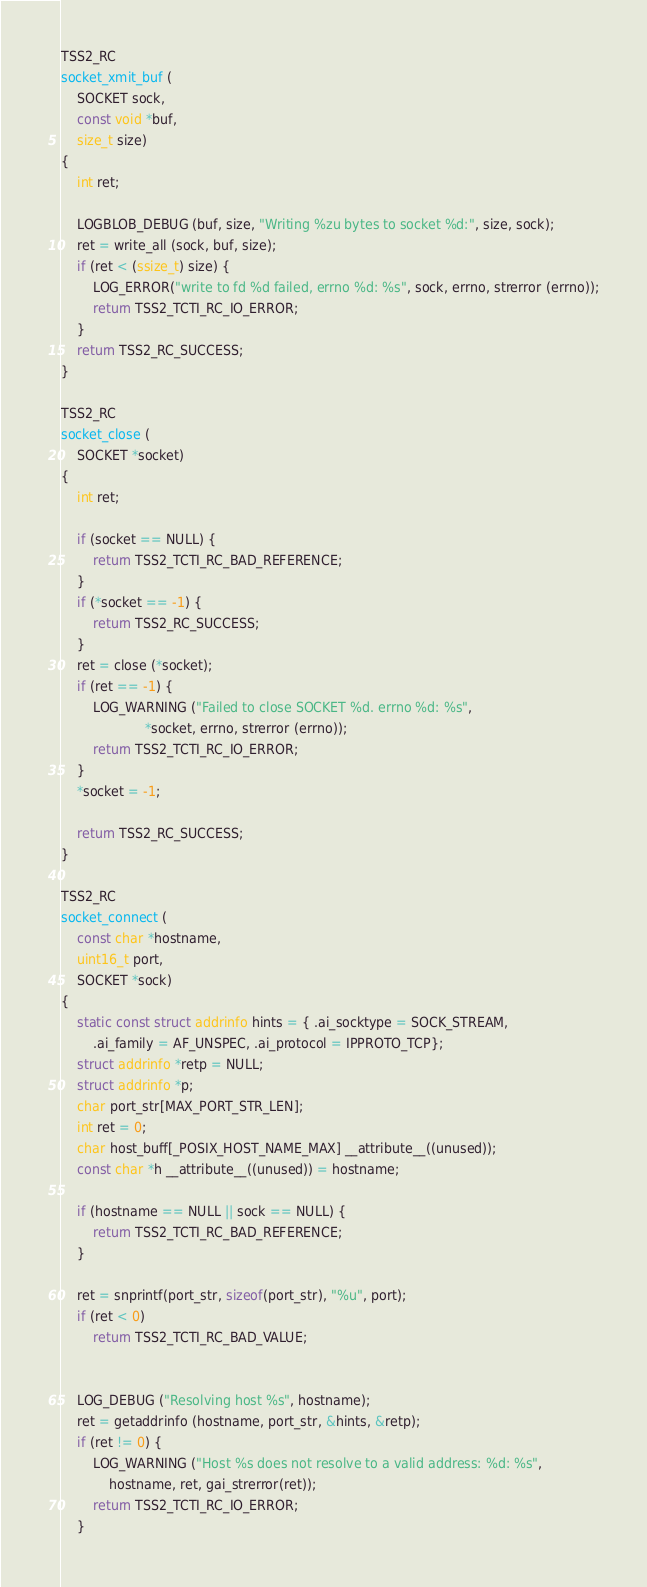<code> <loc_0><loc_0><loc_500><loc_500><_C_>TSS2_RC
socket_xmit_buf (
    SOCKET sock,
    const void *buf,
    size_t size)
{
    int ret;

    LOGBLOB_DEBUG (buf, size, "Writing %zu bytes to socket %d:", size, sock);
    ret = write_all (sock, buf, size);
    if (ret < (ssize_t) size) {
        LOG_ERROR("write to fd %d failed, errno %d: %s", sock, errno, strerror (errno));
        return TSS2_TCTI_RC_IO_ERROR;
    }
    return TSS2_RC_SUCCESS;
}

TSS2_RC
socket_close (
    SOCKET *socket)
{
    int ret;

    if (socket == NULL) {
        return TSS2_TCTI_RC_BAD_REFERENCE;
    }
    if (*socket == -1) {
        return TSS2_RC_SUCCESS;
    }
    ret = close (*socket);
    if (ret == -1) {
        LOG_WARNING ("Failed to close SOCKET %d. errno %d: %s",
                     *socket, errno, strerror (errno));
        return TSS2_TCTI_RC_IO_ERROR;
    }
    *socket = -1;

    return TSS2_RC_SUCCESS;
}

TSS2_RC
socket_connect (
    const char *hostname,
    uint16_t port,
    SOCKET *sock)
{
    static const struct addrinfo hints = { .ai_socktype = SOCK_STREAM,
        .ai_family = AF_UNSPEC, .ai_protocol = IPPROTO_TCP};
    struct addrinfo *retp = NULL;
    struct addrinfo *p;
    char port_str[MAX_PORT_STR_LEN];
    int ret = 0;
    char host_buff[_POSIX_HOST_NAME_MAX] __attribute__((unused));
    const char *h __attribute__((unused)) = hostname;

    if (hostname == NULL || sock == NULL) {
        return TSS2_TCTI_RC_BAD_REFERENCE;
    }

    ret = snprintf(port_str, sizeof(port_str), "%u", port);
    if (ret < 0)
        return TSS2_TCTI_RC_BAD_VALUE;


    LOG_DEBUG ("Resolving host %s", hostname);
    ret = getaddrinfo (hostname, port_str, &hints, &retp);
    if (ret != 0) {
        LOG_WARNING ("Host %s does not resolve to a valid address: %d: %s",
            hostname, ret, gai_strerror(ret));
        return TSS2_TCTI_RC_IO_ERROR;
    }
</code> 